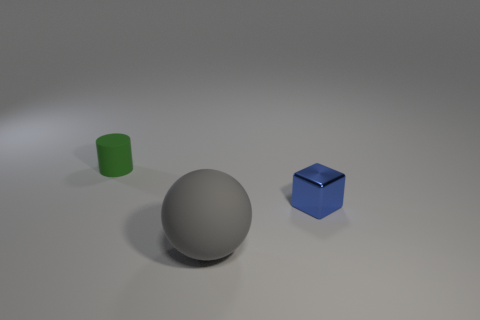Subtract 1 balls. How many balls are left? 0 Subtract all cyan spheres. How many red blocks are left? 0 Subtract all cylinders. Subtract all small rubber cylinders. How many objects are left? 1 Add 2 green matte cylinders. How many green matte cylinders are left? 3 Add 2 small objects. How many small objects exist? 4 Add 1 gray rubber balls. How many objects exist? 4 Subtract 0 gray cylinders. How many objects are left? 3 Subtract all purple cubes. Subtract all red balls. How many cubes are left? 1 